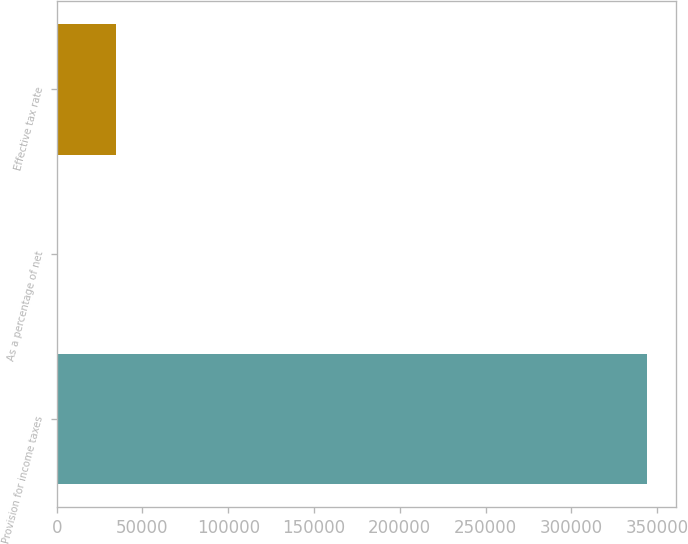Convert chart to OTSL. <chart><loc_0><loc_0><loc_500><loc_500><bar_chart><fcel>Provision for income taxes<fcel>As a percentage of net<fcel>Effective tax rate<nl><fcel>343885<fcel>10.5<fcel>34397.9<nl></chart> 